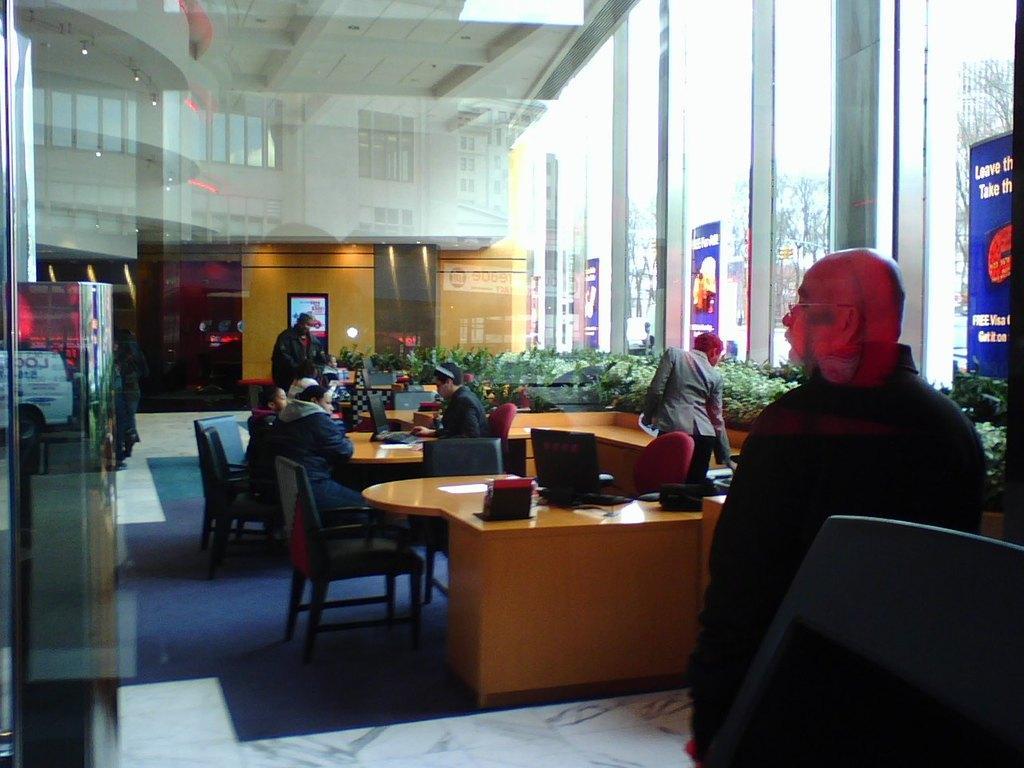In one or two sentences, can you explain what this image depicts? there is an office,we can see many people some people are sitting and working with a laptop and other people are standing we can also see some plants some hoardings. 